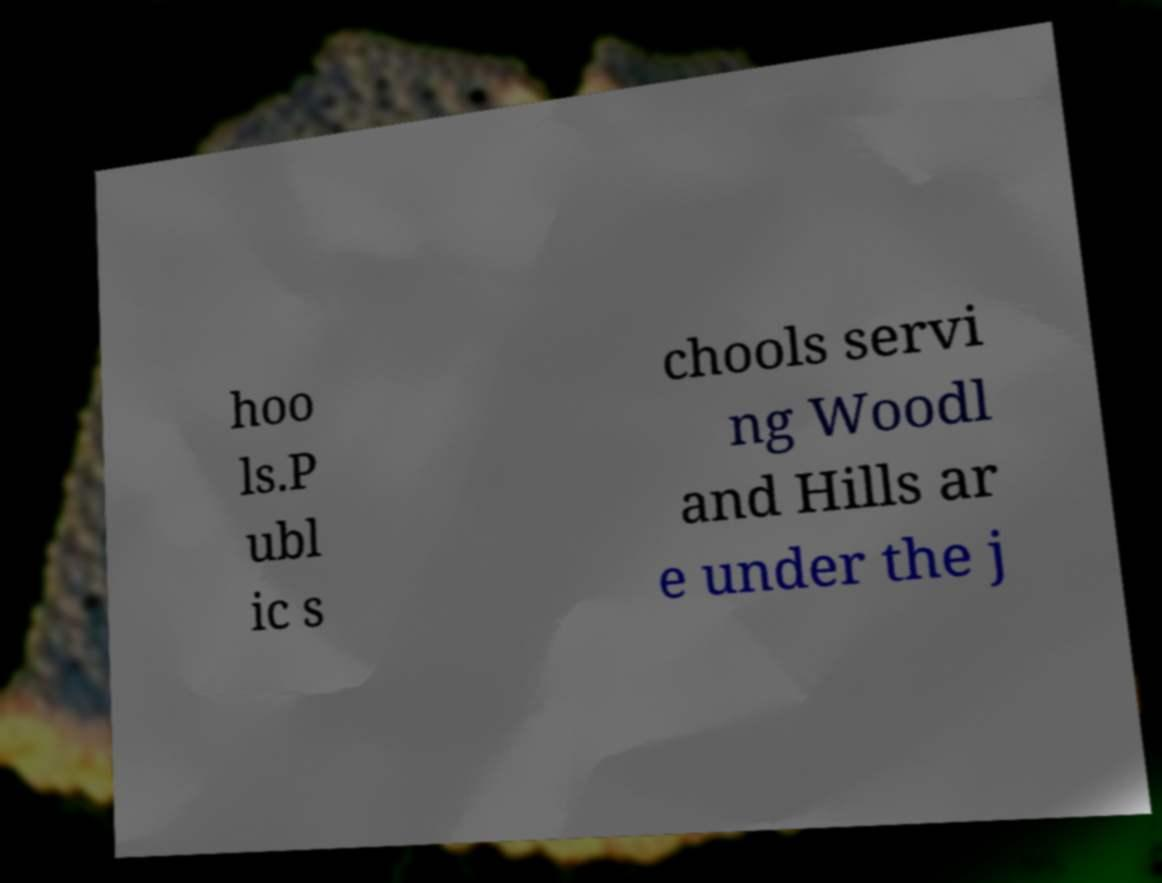Could you assist in decoding the text presented in this image and type it out clearly? hoo ls.P ubl ic s chools servi ng Woodl and Hills ar e under the j 